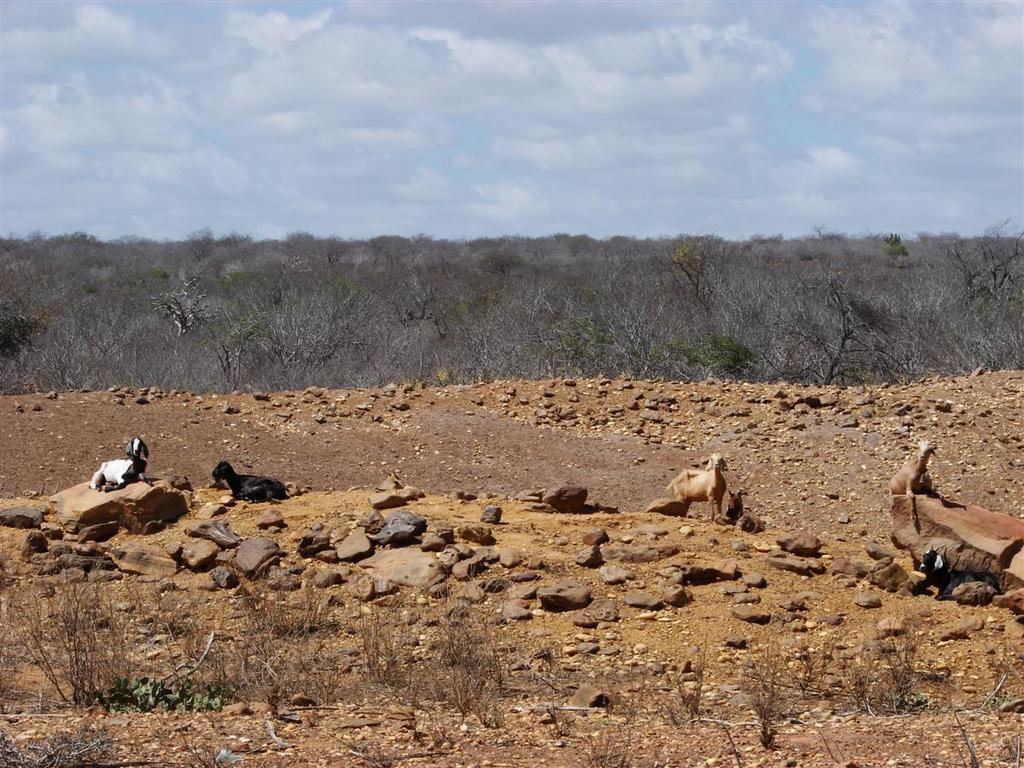Describe this image in one or two sentences. In this image we can see group of animals on the surface. In the foreground we can see some plants and rocks. In the background, we can see a group of trees and the cloudy sky. 